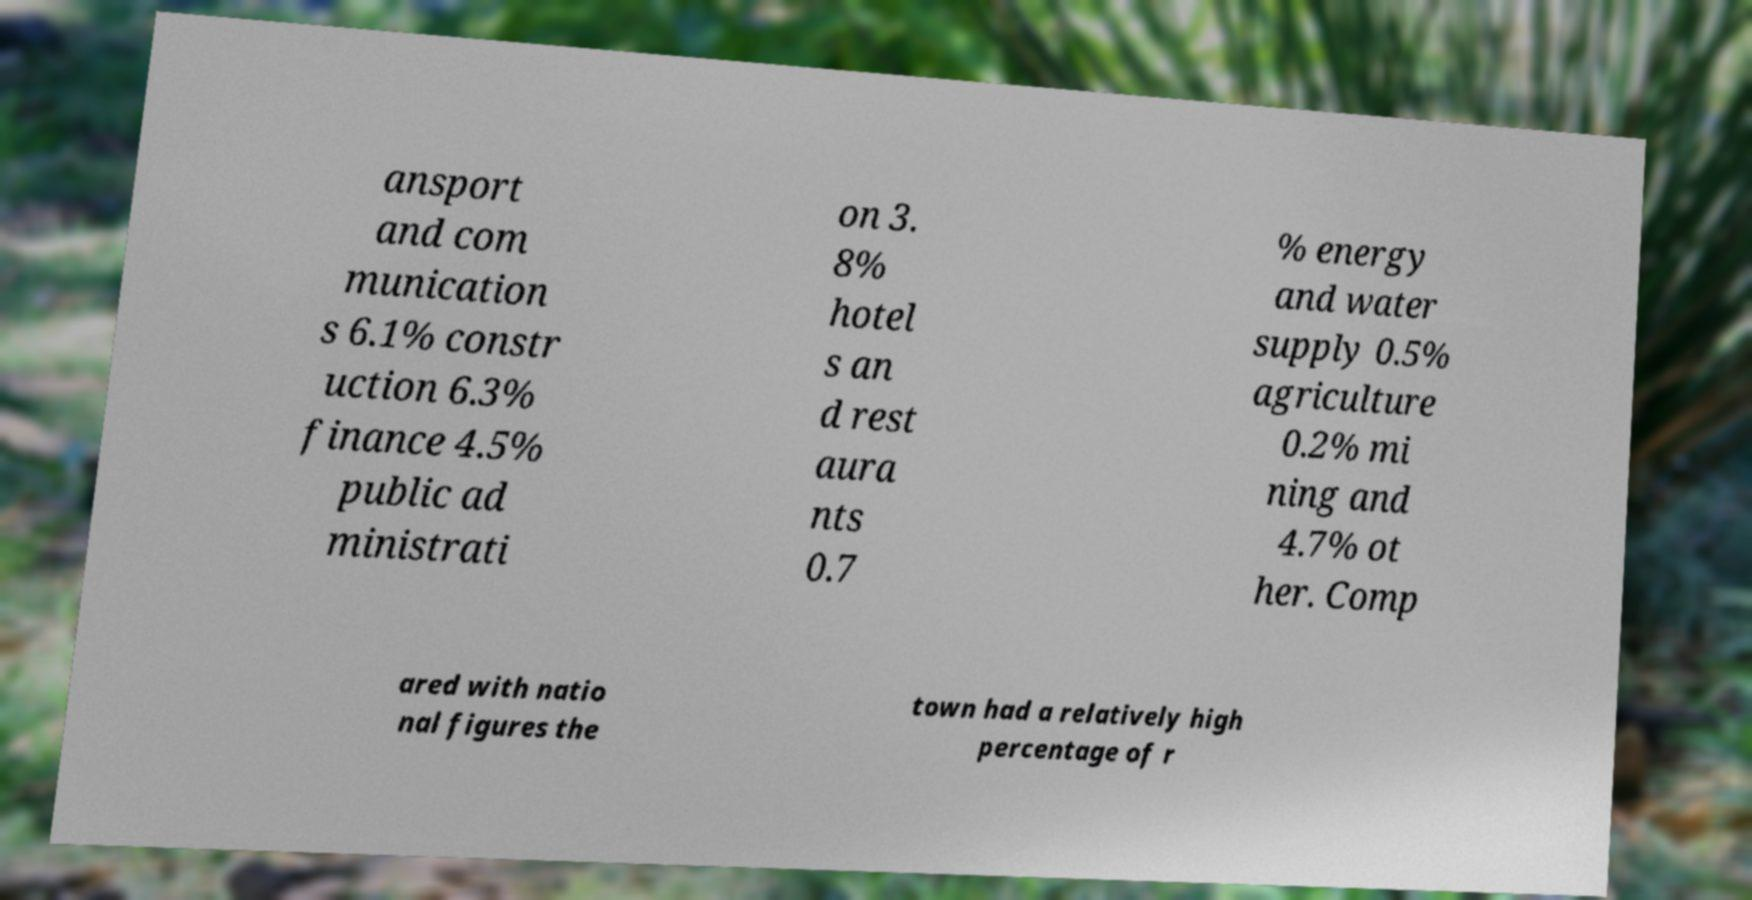Please identify and transcribe the text found in this image. ansport and com munication s 6.1% constr uction 6.3% finance 4.5% public ad ministrati on 3. 8% hotel s an d rest aura nts 0.7 % energy and water supply 0.5% agriculture 0.2% mi ning and 4.7% ot her. Comp ared with natio nal figures the town had a relatively high percentage of r 